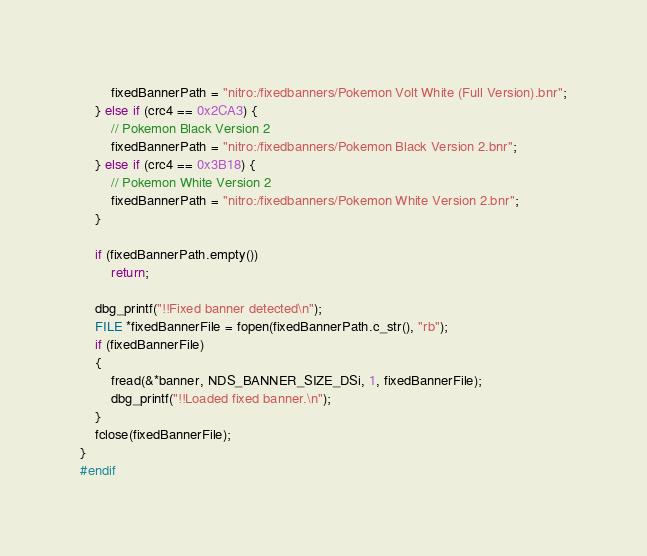<code> <loc_0><loc_0><loc_500><loc_500><_C_>        fixedBannerPath = "nitro:/fixedbanners/Pokemon Volt White (Full Version).bnr";
    } else if (crc4 == 0x2CA3) {
        // Pokemon Black Version 2
        fixedBannerPath = "nitro:/fixedbanners/Pokemon Black Version 2.bnr";
    } else if (crc4 == 0x3B18) {
        // Pokemon White Version 2
        fixedBannerPath = "nitro:/fixedbanners/Pokemon White Version 2.bnr";
    }

    if (fixedBannerPath.empty())
        return;

    dbg_printf("!!Fixed banner detected\n");
    FILE *fixedBannerFile = fopen(fixedBannerPath.c_str(), "rb");
    if (fixedBannerFile)
    {
        fread(&*banner, NDS_BANNER_SIZE_DSi, 1, fixedBannerFile);
        dbg_printf("!!Loaded fixed banner.\n");
    }
    fclose(fixedBannerFile);
}
#endif</code> 